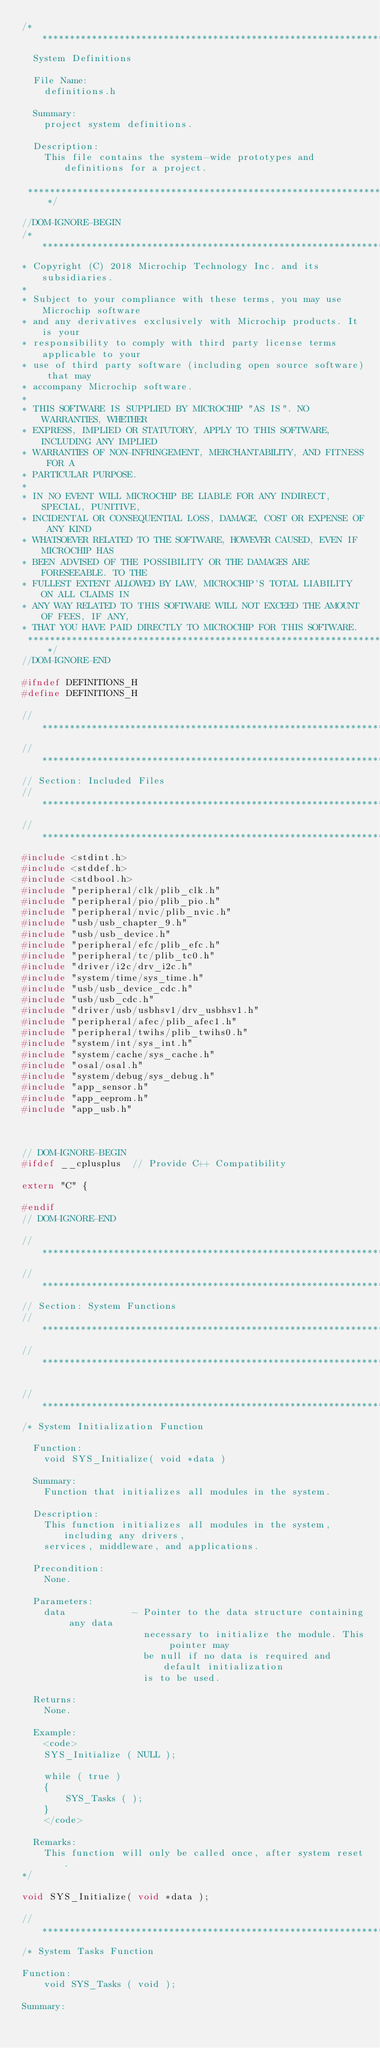Convert code to text. <code><loc_0><loc_0><loc_500><loc_500><_C_>/*******************************************************************************
  System Definitions

  File Name:
    definitions.h

  Summary:
    project system definitions.

  Description:
    This file contains the system-wide prototypes and definitions for a project.

 *******************************************************************************/

//DOM-IGNORE-BEGIN
/*******************************************************************************
* Copyright (C) 2018 Microchip Technology Inc. and its subsidiaries.
*
* Subject to your compliance with these terms, you may use Microchip software
* and any derivatives exclusively with Microchip products. It is your
* responsibility to comply with third party license terms applicable to your
* use of third party software (including open source software) that may
* accompany Microchip software.
*
* THIS SOFTWARE IS SUPPLIED BY MICROCHIP "AS IS". NO WARRANTIES, WHETHER
* EXPRESS, IMPLIED OR STATUTORY, APPLY TO THIS SOFTWARE, INCLUDING ANY IMPLIED
* WARRANTIES OF NON-INFRINGEMENT, MERCHANTABILITY, AND FITNESS FOR A
* PARTICULAR PURPOSE.
*
* IN NO EVENT WILL MICROCHIP BE LIABLE FOR ANY INDIRECT, SPECIAL, PUNITIVE,
* INCIDENTAL OR CONSEQUENTIAL LOSS, DAMAGE, COST OR EXPENSE OF ANY KIND
* WHATSOEVER RELATED TO THE SOFTWARE, HOWEVER CAUSED, EVEN IF MICROCHIP HAS
* BEEN ADVISED OF THE POSSIBILITY OR THE DAMAGES ARE FORESEEABLE. TO THE
* FULLEST EXTENT ALLOWED BY LAW, MICROCHIP'S TOTAL LIABILITY ON ALL CLAIMS IN
* ANY WAY RELATED TO THIS SOFTWARE WILL NOT EXCEED THE AMOUNT OF FEES, IF ANY,
* THAT YOU HAVE PAID DIRECTLY TO MICROCHIP FOR THIS SOFTWARE.
 *******************************************************************************/
//DOM-IGNORE-END

#ifndef DEFINITIONS_H
#define DEFINITIONS_H

// *****************************************************************************
// *****************************************************************************
// Section: Included Files
// *****************************************************************************
// *****************************************************************************
#include <stdint.h>
#include <stddef.h>
#include <stdbool.h>
#include "peripheral/clk/plib_clk.h"
#include "peripheral/pio/plib_pio.h"
#include "peripheral/nvic/plib_nvic.h"
#include "usb/usb_chapter_9.h"
#include "usb/usb_device.h"
#include "peripheral/efc/plib_efc.h"
#include "peripheral/tc/plib_tc0.h"
#include "driver/i2c/drv_i2c.h"
#include "system/time/sys_time.h"
#include "usb/usb_device_cdc.h"
#include "usb/usb_cdc.h"
#include "driver/usb/usbhsv1/drv_usbhsv1.h"
#include "peripheral/afec/plib_afec1.h"
#include "peripheral/twihs/plib_twihs0.h"
#include "system/int/sys_int.h"
#include "system/cache/sys_cache.h"
#include "osal/osal.h"
#include "system/debug/sys_debug.h"
#include "app_sensor.h"
#include "app_eeprom.h"
#include "app_usb.h"



// DOM-IGNORE-BEGIN
#ifdef __cplusplus  // Provide C++ Compatibility

extern "C" {

#endif
// DOM-IGNORE-END

// *****************************************************************************
// *****************************************************************************
// Section: System Functions
// *****************************************************************************
// *****************************************************************************

// *****************************************************************************
/* System Initialization Function

  Function:
    void SYS_Initialize( void *data )

  Summary:
    Function that initializes all modules in the system.

  Description:
    This function initializes all modules in the system, including any drivers,
    services, middleware, and applications.

  Precondition:
    None.

  Parameters:
    data            - Pointer to the data structure containing any data
                      necessary to initialize the module. This pointer may
                      be null if no data is required and default initialization
                      is to be used.

  Returns:
    None.

  Example:
    <code>
    SYS_Initialize ( NULL );

    while ( true )
    {
        SYS_Tasks ( );
    }
    </code>

  Remarks:
    This function will only be called once, after system reset.
*/

void SYS_Initialize( void *data );

// *****************************************************************************
/* System Tasks Function

Function:
    void SYS_Tasks ( void );

Summary:</code> 